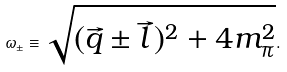<formula> <loc_0><loc_0><loc_500><loc_500>\omega _ { \pm } \equiv \sqrt { ( \vec { q } \pm \vec { l } \, ) ^ { 2 } + 4 m _ { \pi } ^ { 2 } } .</formula> 